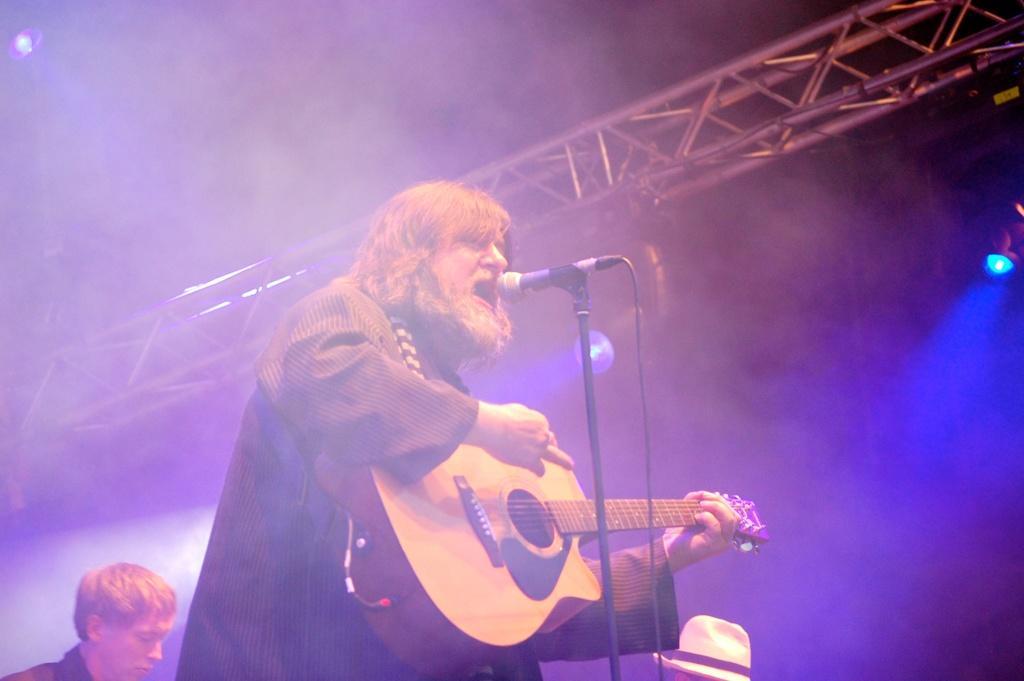Can you describe this image briefly? a person is playing guitar and singing in the microphone. behind him at the left there is another person. at the right there is a white color hat. 